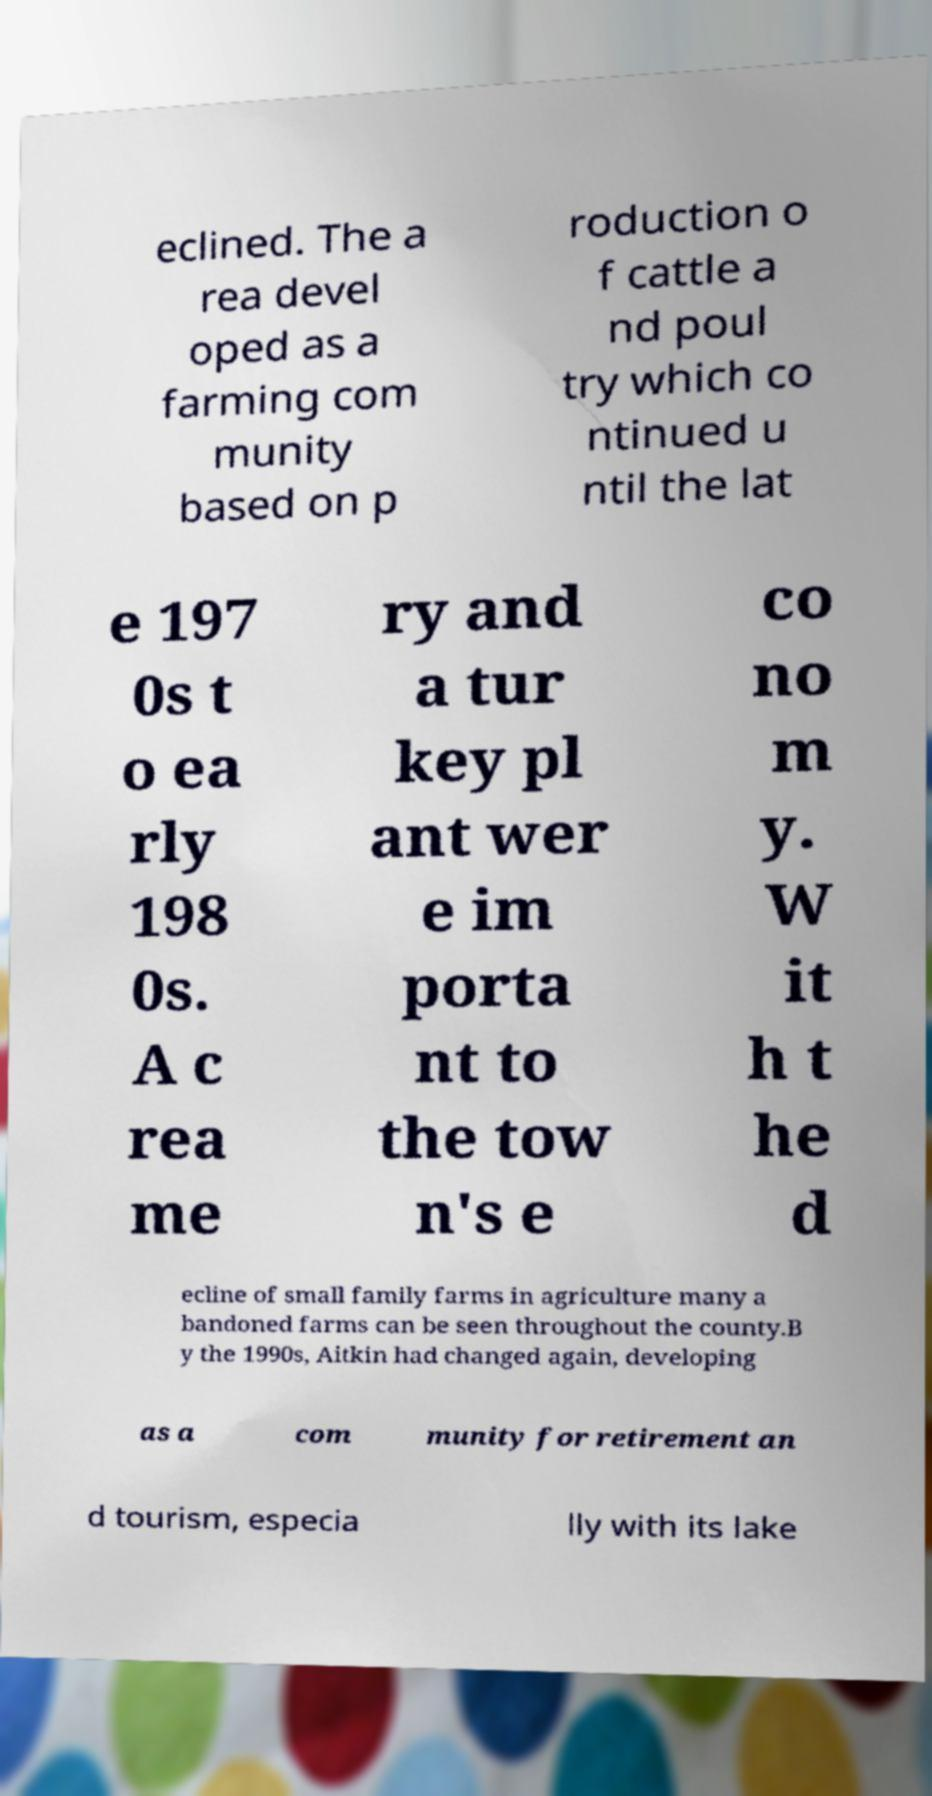I need the written content from this picture converted into text. Can you do that? eclined. The a rea devel oped as a farming com munity based on p roduction o f cattle a nd poul try which co ntinued u ntil the lat e 197 0s t o ea rly 198 0s. A c rea me ry and a tur key pl ant wer e im porta nt to the tow n's e co no m y. W it h t he d ecline of small family farms in agriculture many a bandoned farms can be seen throughout the county.B y the 1990s, Aitkin had changed again, developing as a com munity for retirement an d tourism, especia lly with its lake 